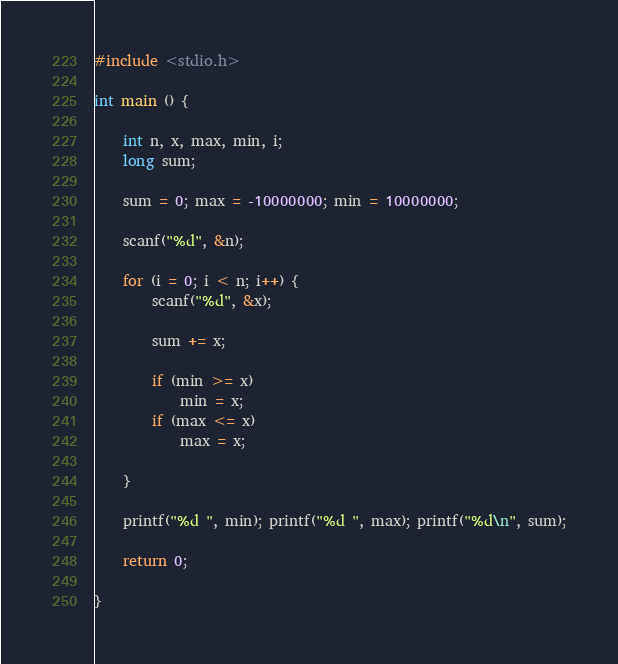<code> <loc_0><loc_0><loc_500><loc_500><_C_>#include <stdio.h>

int main () {

    int n, x, max, min, i;
    long sum;

    sum = 0; max = -10000000; min = 10000000;

    scanf("%d", &n);

    for (i = 0; i < n; i++) {
        scanf("%d", &x);

        sum += x;

        if (min >= x)
            min = x;
        if (max <= x)
            max = x;

    }

    printf("%d ", min); printf("%d ", max); printf("%d\n", sum);

    return 0;

}


</code> 